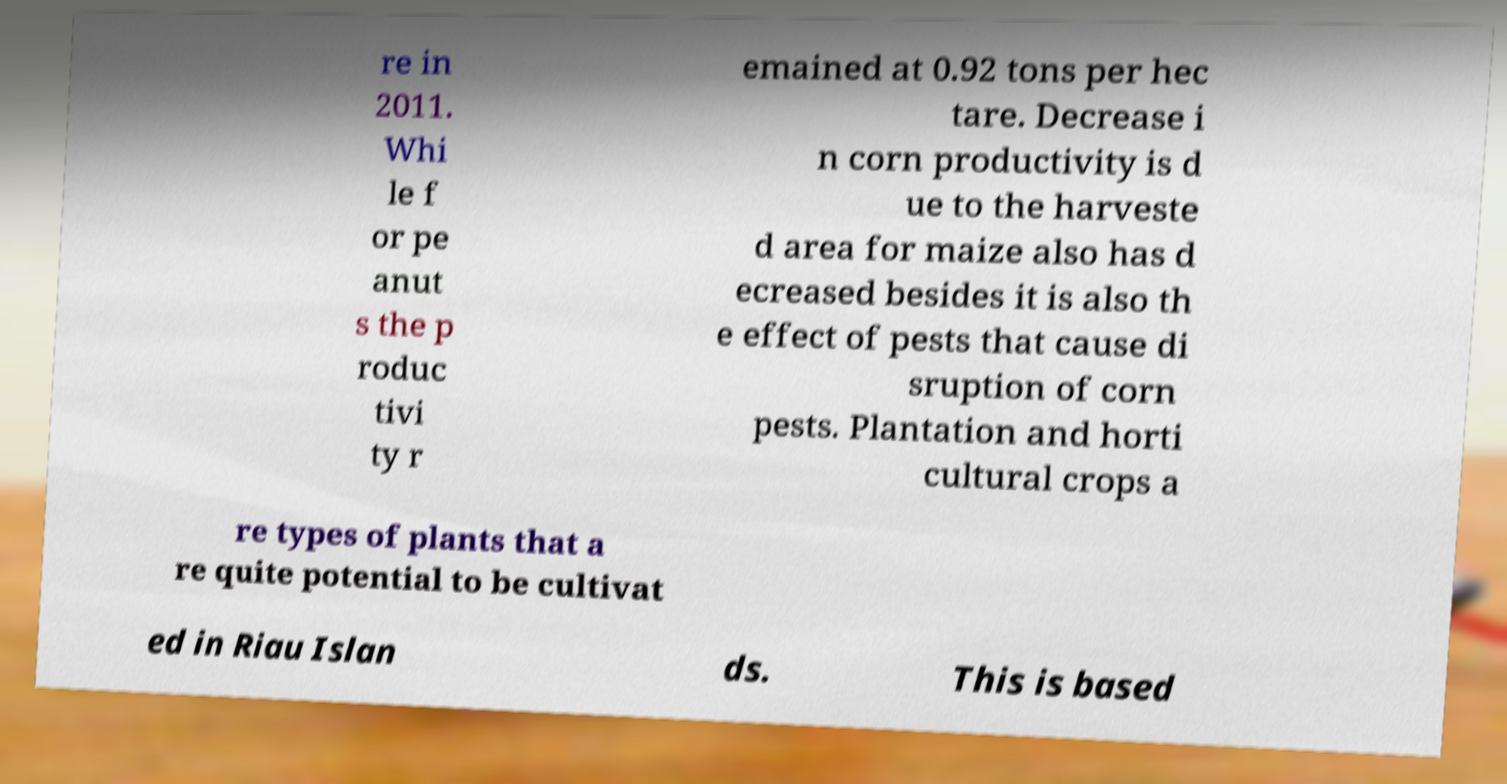Please identify and transcribe the text found in this image. re in 2011. Whi le f or pe anut s the p roduc tivi ty r emained at 0.92 tons per hec tare. Decrease i n corn productivity is d ue to the harveste d area for maize also has d ecreased besides it is also th e effect of pests that cause di sruption of corn pests. Plantation and horti cultural crops a re types of plants that a re quite potential to be cultivat ed in Riau Islan ds. This is based 